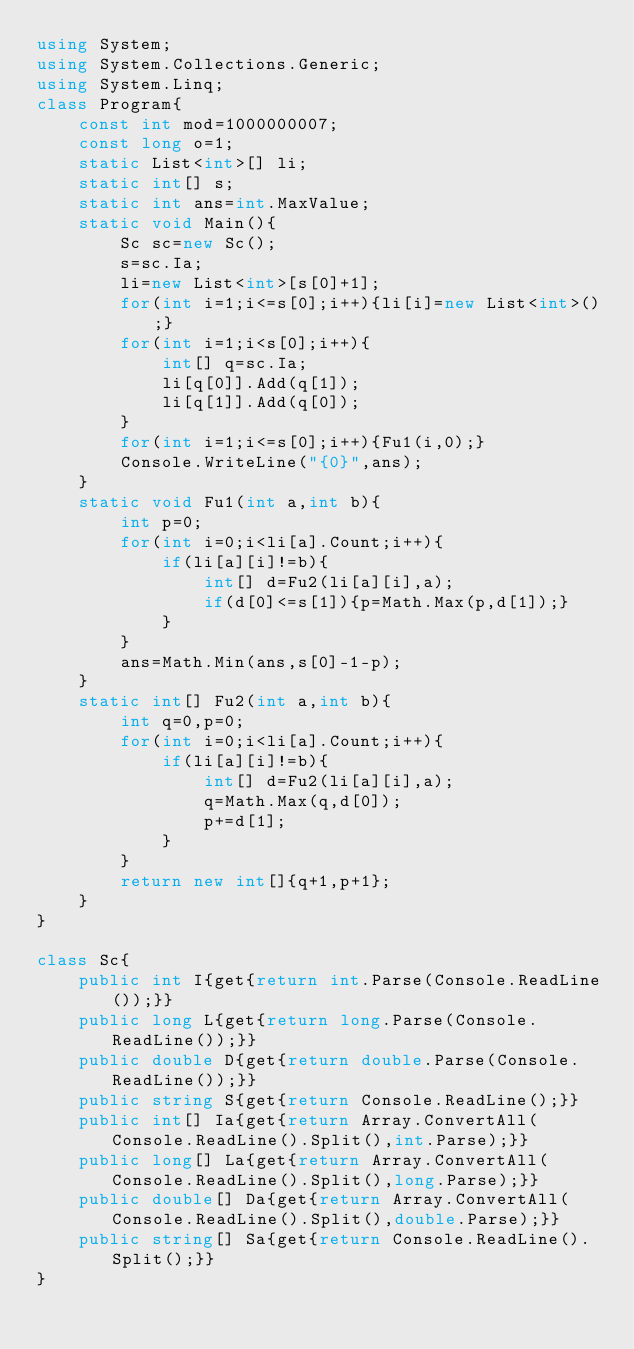Convert code to text. <code><loc_0><loc_0><loc_500><loc_500><_C#_>using System;
using System.Collections.Generic;
using System.Linq;
class Program{
	const int mod=1000000007;
	const long o=1;
	static List<int>[] li;
	static int[] s;
	static int ans=int.MaxValue;
	static void Main(){
		Sc sc=new Sc();
		s=sc.Ia;
		li=new List<int>[s[0]+1];
		for(int i=1;i<=s[0];i++){li[i]=new List<int>();}
		for(int i=1;i<s[0];i++){
			int[] q=sc.Ia;
			li[q[0]].Add(q[1]);
			li[q[1]].Add(q[0]);
		}
		for(int i=1;i<=s[0];i++){Fu1(i,0);}
		Console.WriteLine("{0}",ans);
	}
	static void Fu1(int a,int b){
		int p=0;
		for(int i=0;i<li[a].Count;i++){
			if(li[a][i]!=b){
				int[] d=Fu2(li[a][i],a);
				if(d[0]<=s[1]){p=Math.Max(p,d[1]);}
			}
		}
		ans=Math.Min(ans,s[0]-1-p);
	}
	static int[] Fu2(int a,int b){
		int q=0,p=0;
		for(int i=0;i<li[a].Count;i++){
			if(li[a][i]!=b){
				int[] d=Fu2(li[a][i],a);
				q=Math.Max(q,d[0]);
				p+=d[1];
			}
		}
		return new int[]{q+1,p+1};
	}
}

class Sc{
	public int I{get{return int.Parse(Console.ReadLine());}}
	public long L{get{return long.Parse(Console.ReadLine());}}
	public double D{get{return double.Parse(Console.ReadLine());}}
	public string S{get{return Console.ReadLine();}}
	public int[] Ia{get{return Array.ConvertAll(Console.ReadLine().Split(),int.Parse);}}
	public long[] La{get{return Array.ConvertAll(Console.ReadLine().Split(),long.Parse);}}
	public double[] Da{get{return Array.ConvertAll(Console.ReadLine().Split(),double.Parse);}}
	public string[] Sa{get{return Console.ReadLine().Split();}}
}</code> 